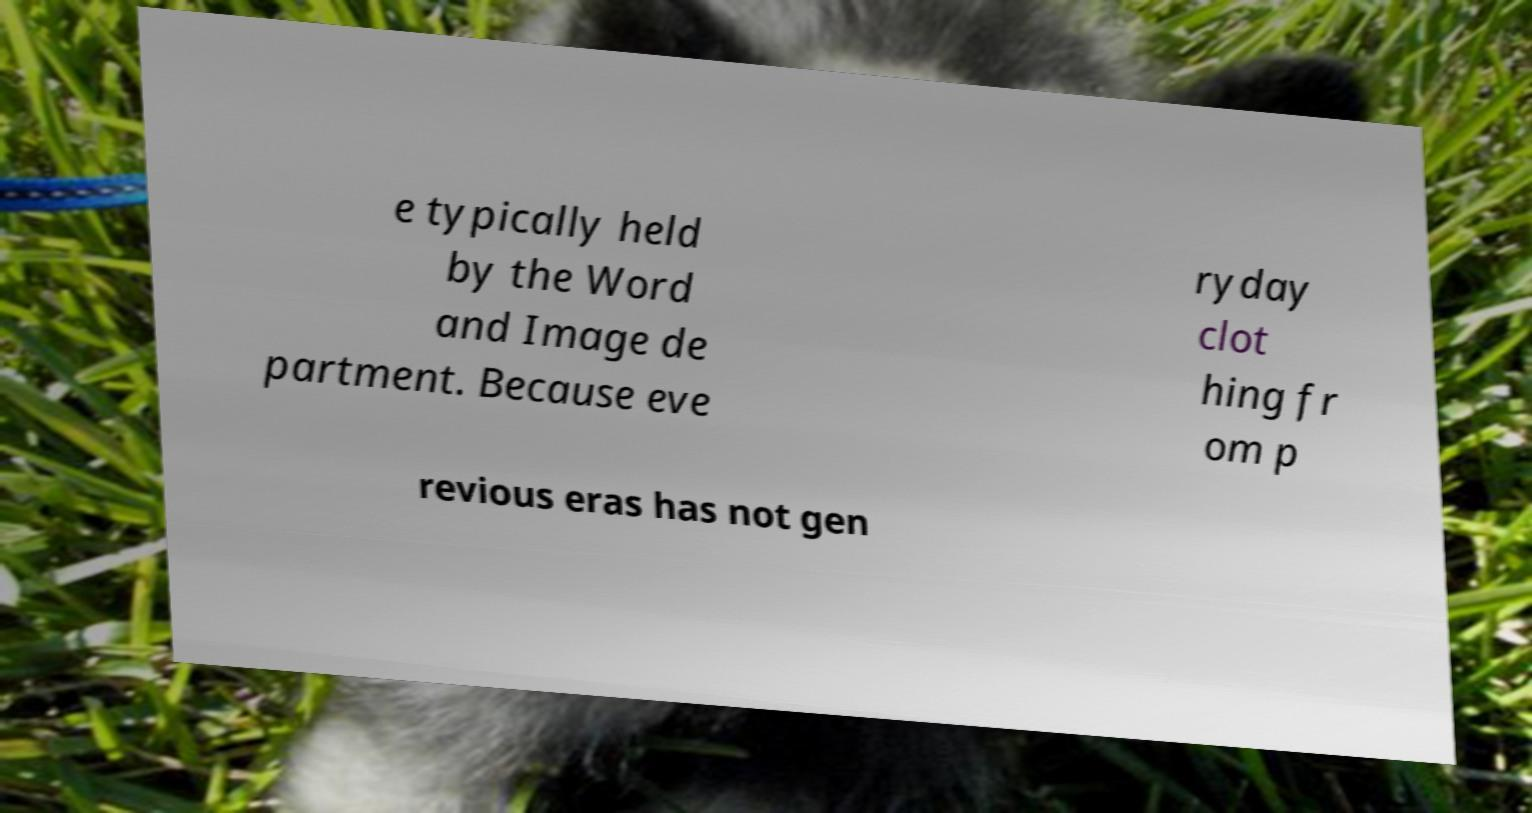For documentation purposes, I need the text within this image transcribed. Could you provide that? e typically held by the Word and Image de partment. Because eve ryday clot hing fr om p revious eras has not gen 